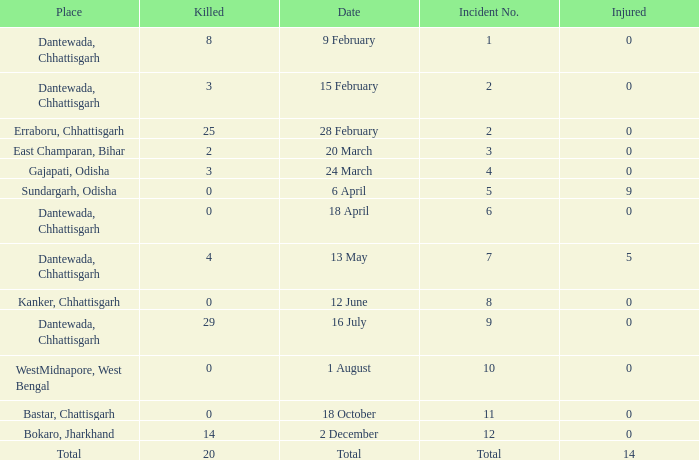How many people were injured in total in East Champaran, Bihar with more than 2 people killed? 0.0. 